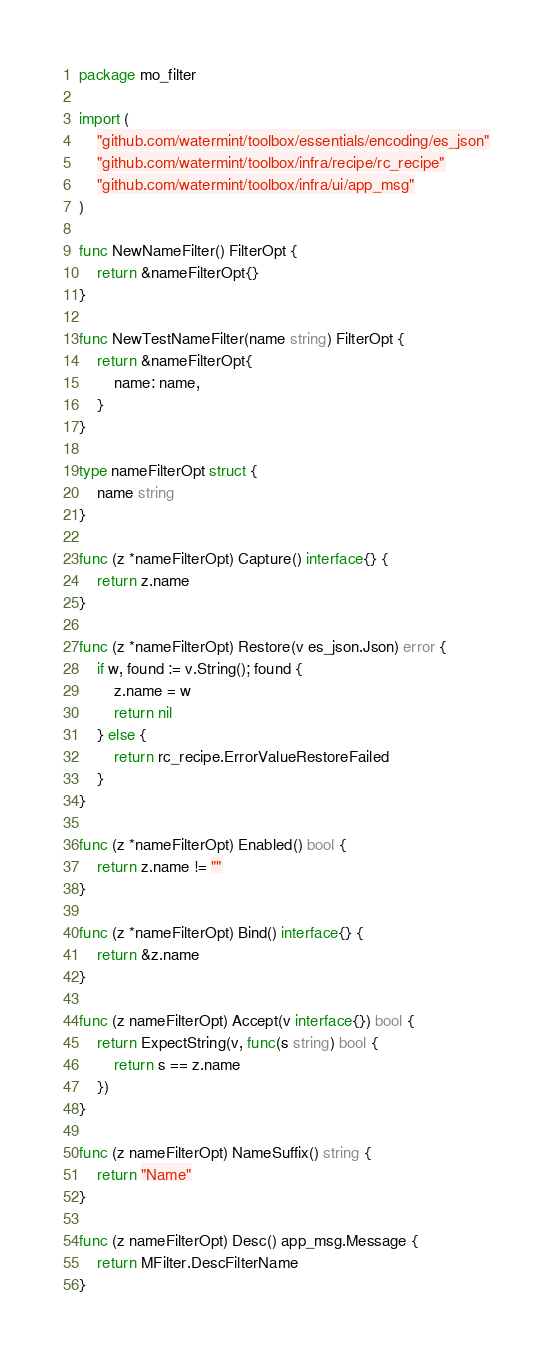Convert code to text. <code><loc_0><loc_0><loc_500><loc_500><_Go_>package mo_filter

import (
	"github.com/watermint/toolbox/essentials/encoding/es_json"
	"github.com/watermint/toolbox/infra/recipe/rc_recipe"
	"github.com/watermint/toolbox/infra/ui/app_msg"
)

func NewNameFilter() FilterOpt {
	return &nameFilterOpt{}
}

func NewTestNameFilter(name string) FilterOpt {
	return &nameFilterOpt{
		name: name,
	}
}

type nameFilterOpt struct {
	name string
}

func (z *nameFilterOpt) Capture() interface{} {
	return z.name
}

func (z *nameFilterOpt) Restore(v es_json.Json) error {
	if w, found := v.String(); found {
		z.name = w
		return nil
	} else {
		return rc_recipe.ErrorValueRestoreFailed
	}
}

func (z *nameFilterOpt) Enabled() bool {
	return z.name != ""
}

func (z *nameFilterOpt) Bind() interface{} {
	return &z.name
}

func (z nameFilterOpt) Accept(v interface{}) bool {
	return ExpectString(v, func(s string) bool {
		return s == z.name
	})
}

func (z nameFilterOpt) NameSuffix() string {
	return "Name"
}

func (z nameFilterOpt) Desc() app_msg.Message {
	return MFilter.DescFilterName
}
</code> 